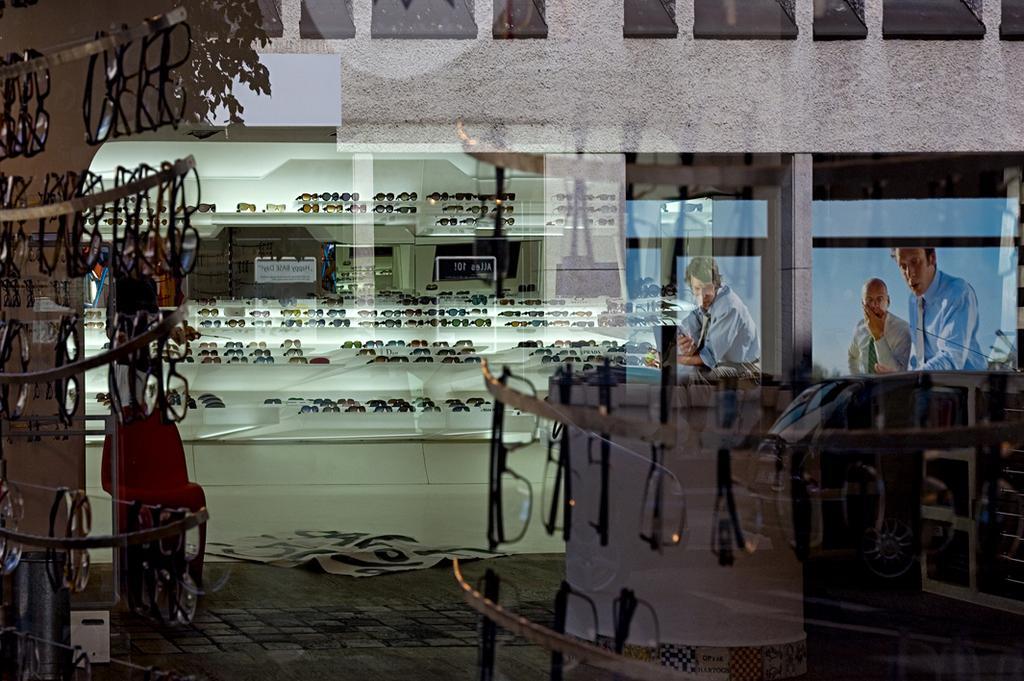How would you summarize this image in a sentence or two? In this picture we can see goggles, racks, and posters. This is floor. In the background we can see a wall and boards. 